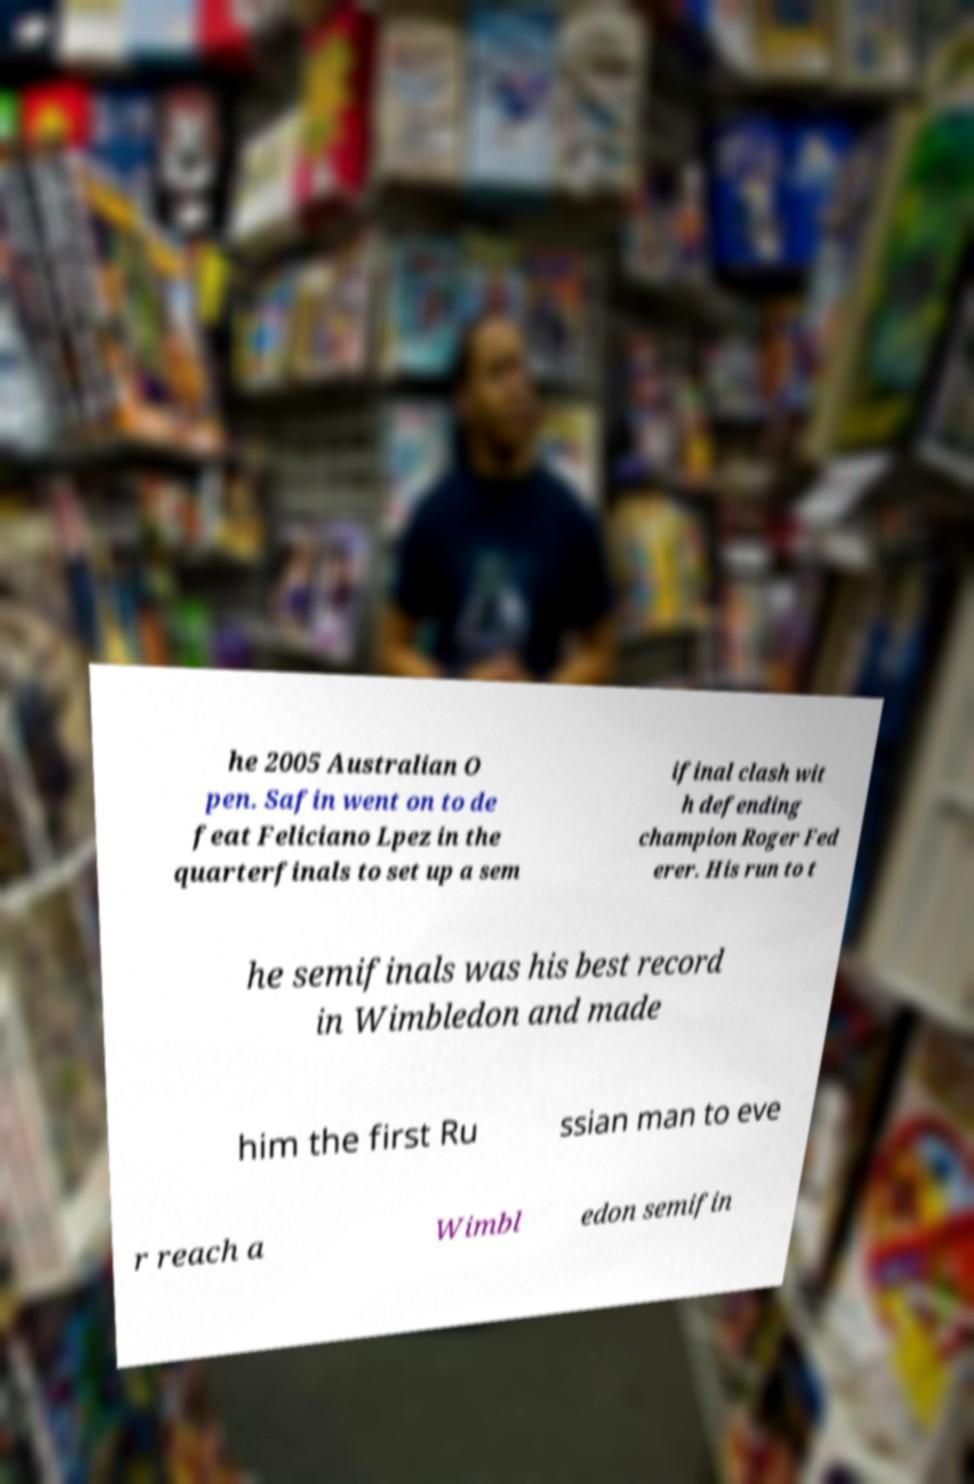Could you extract and type out the text from this image? he 2005 Australian O pen. Safin went on to de feat Feliciano Lpez in the quarterfinals to set up a sem ifinal clash wit h defending champion Roger Fed erer. His run to t he semifinals was his best record in Wimbledon and made him the first Ru ssian man to eve r reach a Wimbl edon semifin 